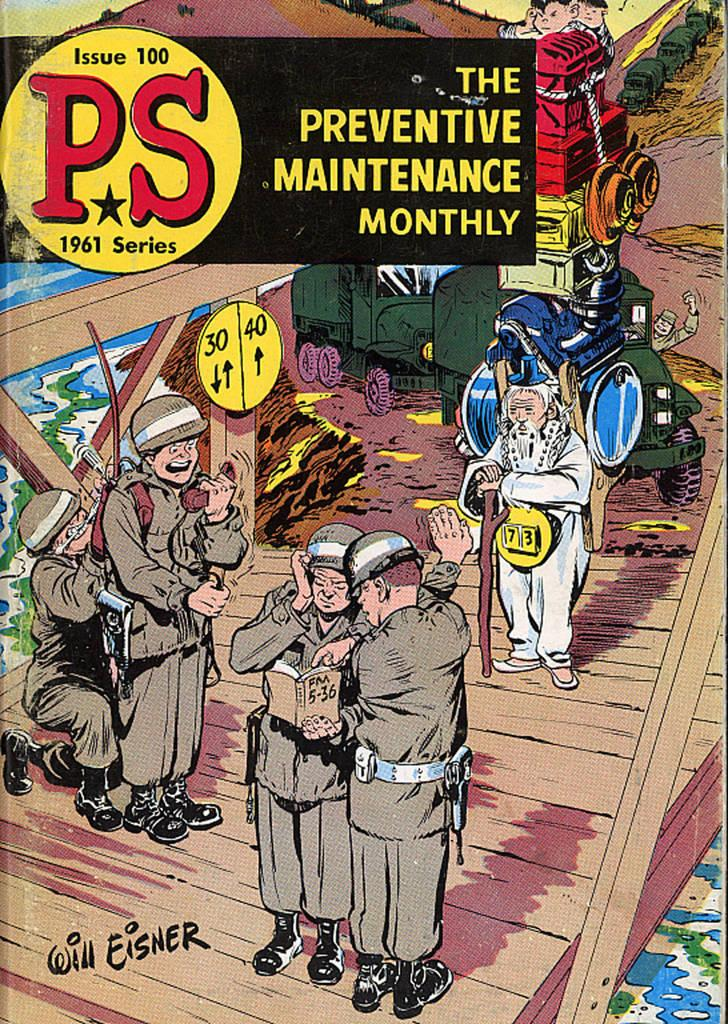Provide a one-sentence caption for the provided image. The cover of PS issue 100 has people in military uniforms and an older man with a walking stick. 